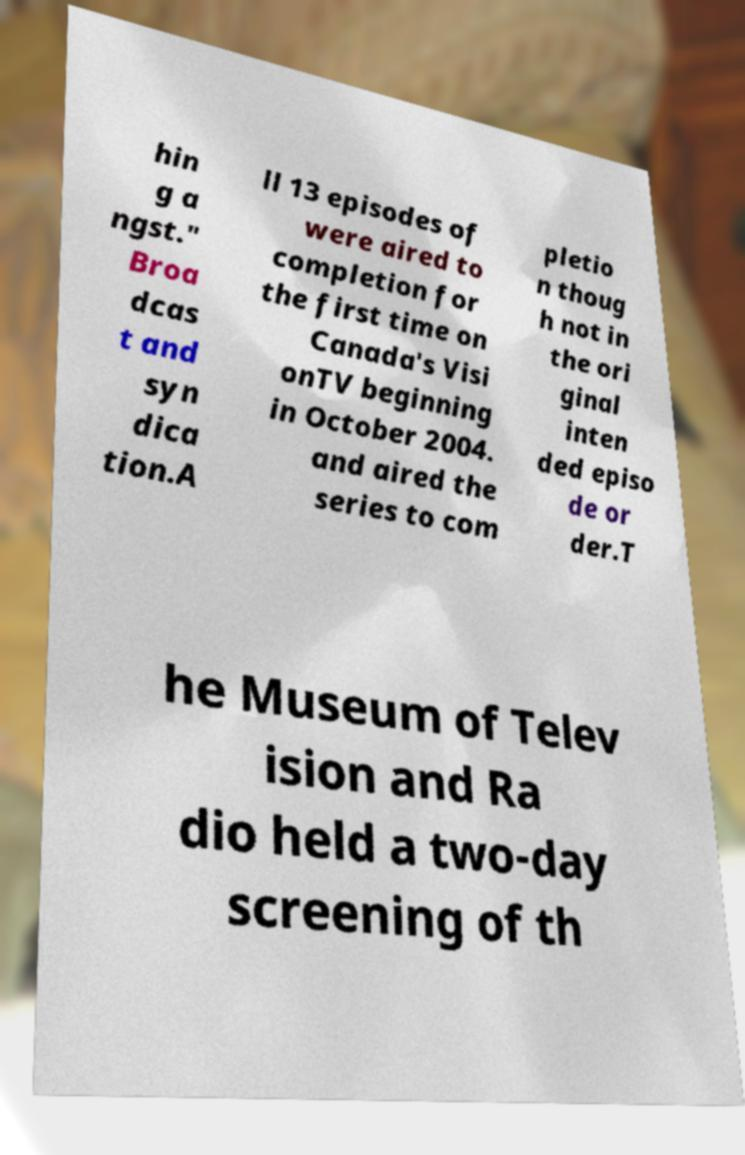Could you extract and type out the text from this image? hin g a ngst." Broa dcas t and syn dica tion.A ll 13 episodes of were aired to completion for the first time on Canada's Visi onTV beginning in October 2004. and aired the series to com pletio n thoug h not in the ori ginal inten ded episo de or der.T he Museum of Telev ision and Ra dio held a two-day screening of th 